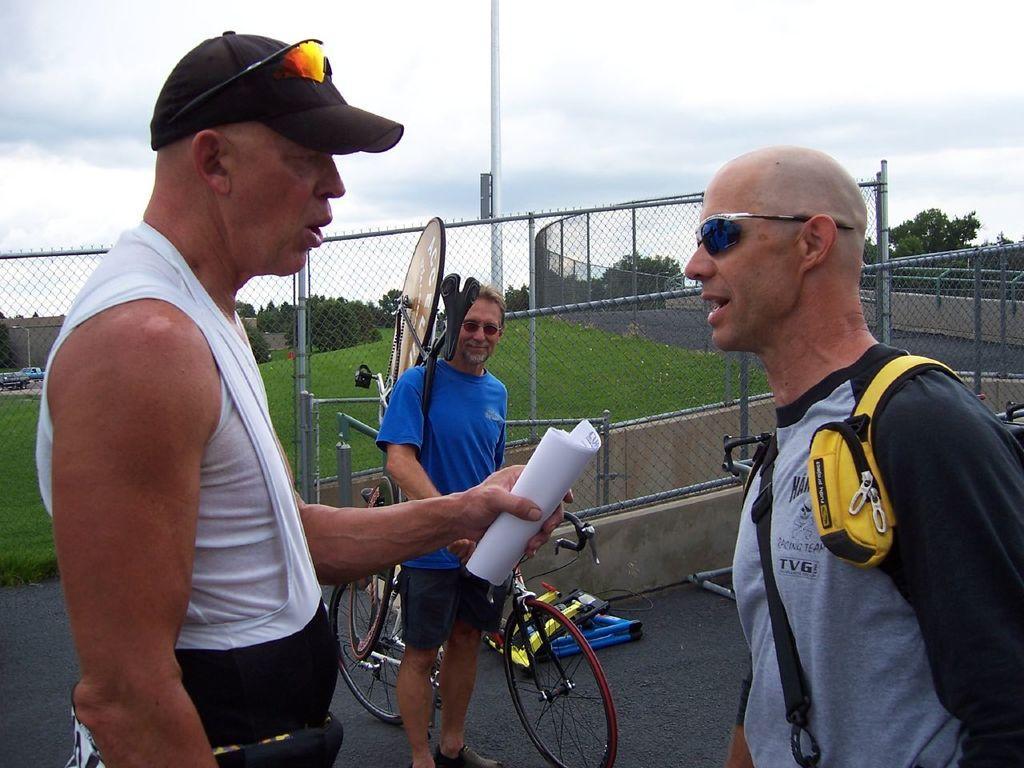Could you give a brief overview of what you see in this image? In this image we can see three persons, one of them is holding papers, another person is carrying a cycle, there is an another cycle beside to him, there is a fencing, there are vehicles, trees, also we can see the sky. 